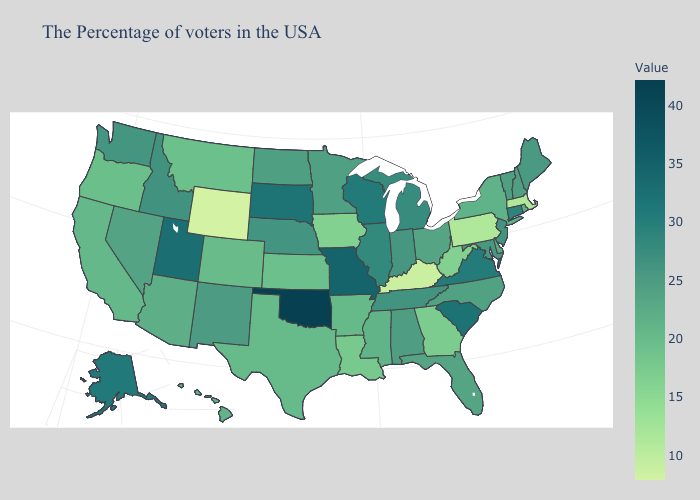Among the states that border Wisconsin , which have the lowest value?
Give a very brief answer. Iowa. Does Arkansas have the highest value in the USA?
Be succinct. No. Among the states that border Texas , does Louisiana have the lowest value?
Concise answer only. Yes. Which states hav the highest value in the West?
Short answer required. Utah. Which states have the lowest value in the West?
Give a very brief answer. Wyoming. Does the map have missing data?
Quick response, please. No. Does North Dakota have the lowest value in the MidWest?
Answer briefly. No. Which states have the highest value in the USA?
Answer briefly. Oklahoma. 